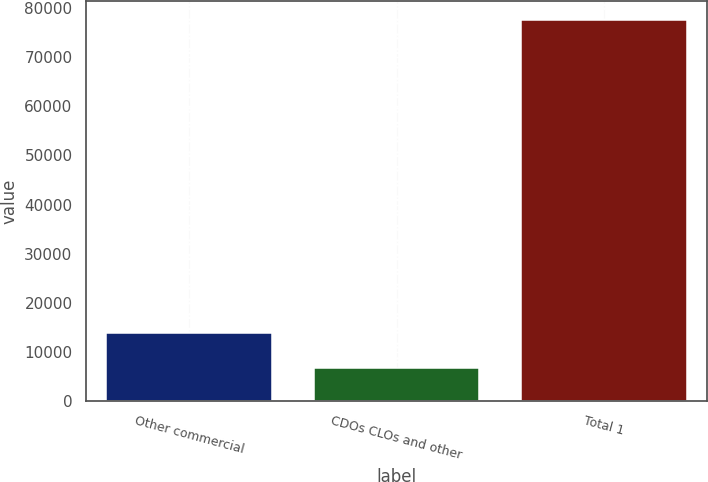Convert chart to OTSL. <chart><loc_0><loc_0><loc_500><loc_500><bar_chart><fcel>Other commercial<fcel>CDOs CLOs and other<fcel>Total 1<nl><fcel>13931.2<fcel>6861<fcel>77563<nl></chart> 